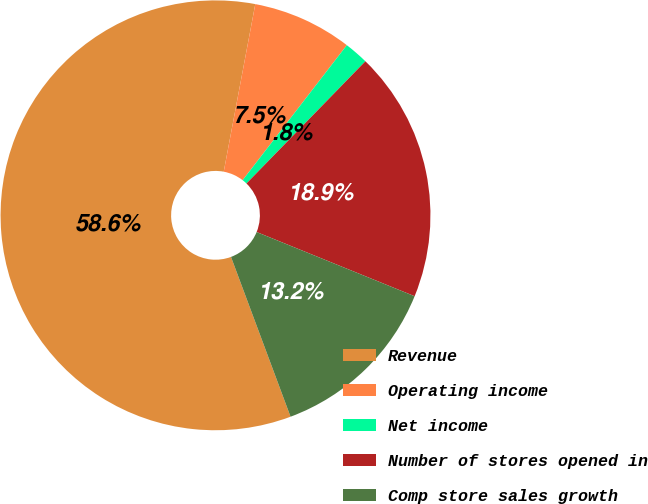<chart> <loc_0><loc_0><loc_500><loc_500><pie_chart><fcel>Revenue<fcel>Operating income<fcel>Net income<fcel>Number of stores opened in<fcel>Comp store sales growth<nl><fcel>58.64%<fcel>7.5%<fcel>1.82%<fcel>18.86%<fcel>13.18%<nl></chart> 